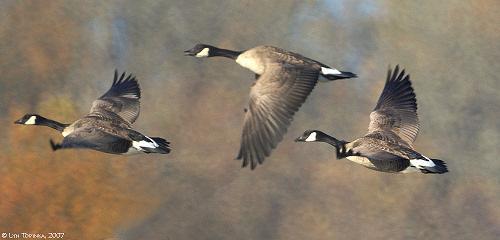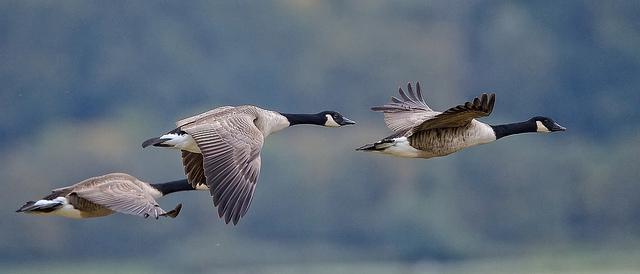The first image is the image on the left, the second image is the image on the right. For the images shown, is this caption "One image shows at least four black-necked geese flying leftward, and the other image shows no more than two geese flying and they do not have black necks." true? Answer yes or no. No. The first image is the image on the left, the second image is the image on the right. Assess this claim about the two images: "There is no more than two ducks in the left image.". Correct or not? Answer yes or no. No. 